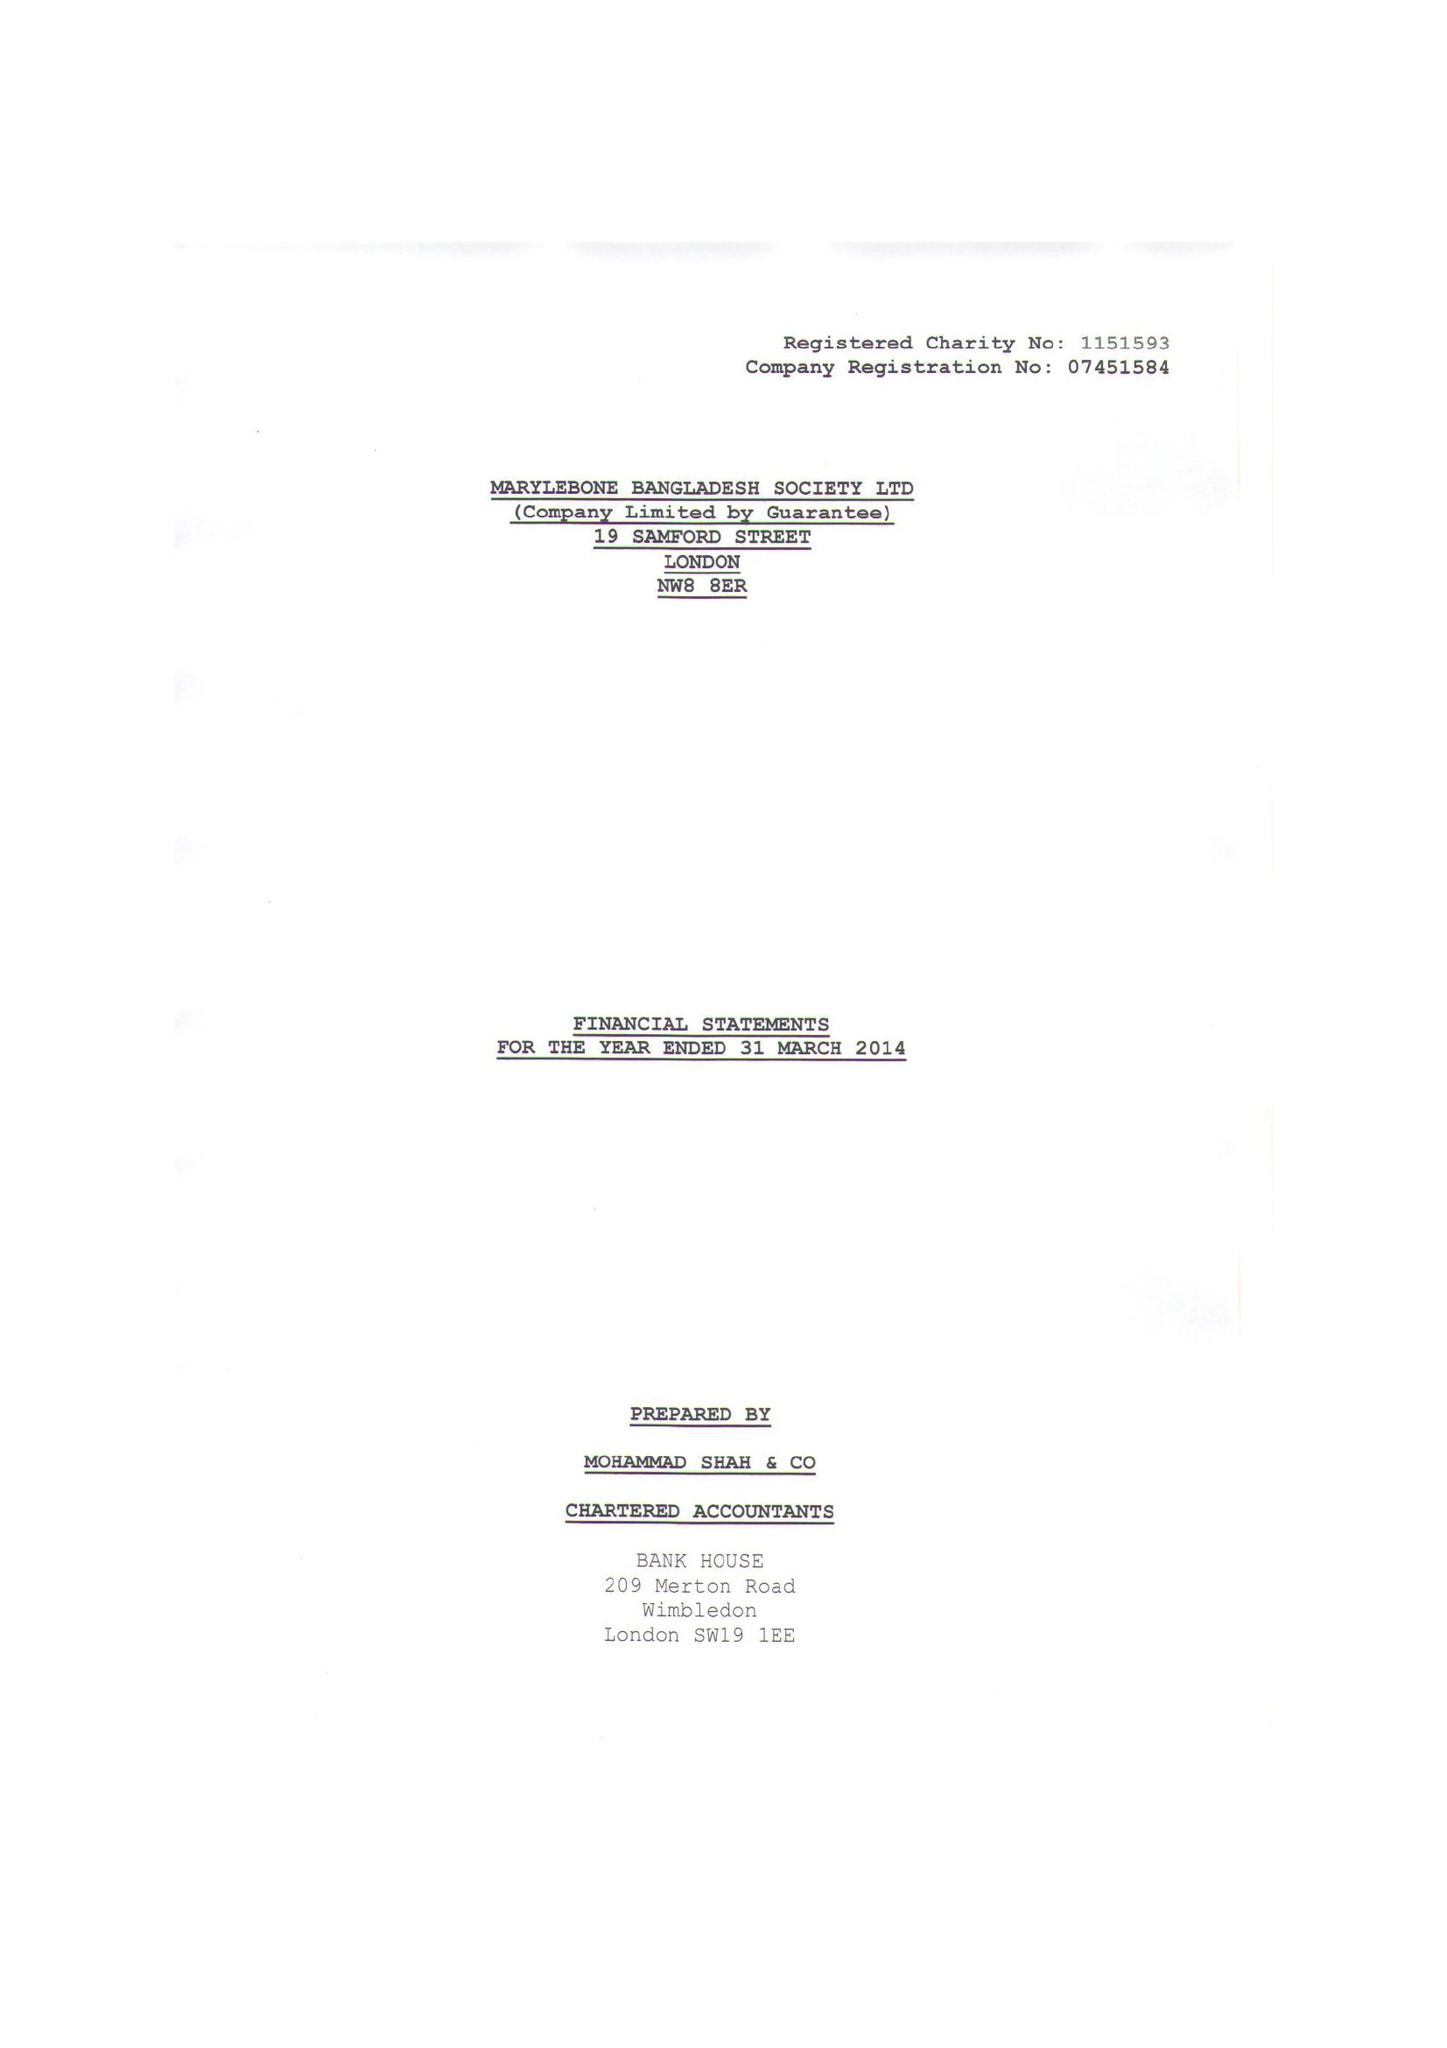What is the value for the address__street_line?
Answer the question using a single word or phrase. 19 SAMFORD STREET 